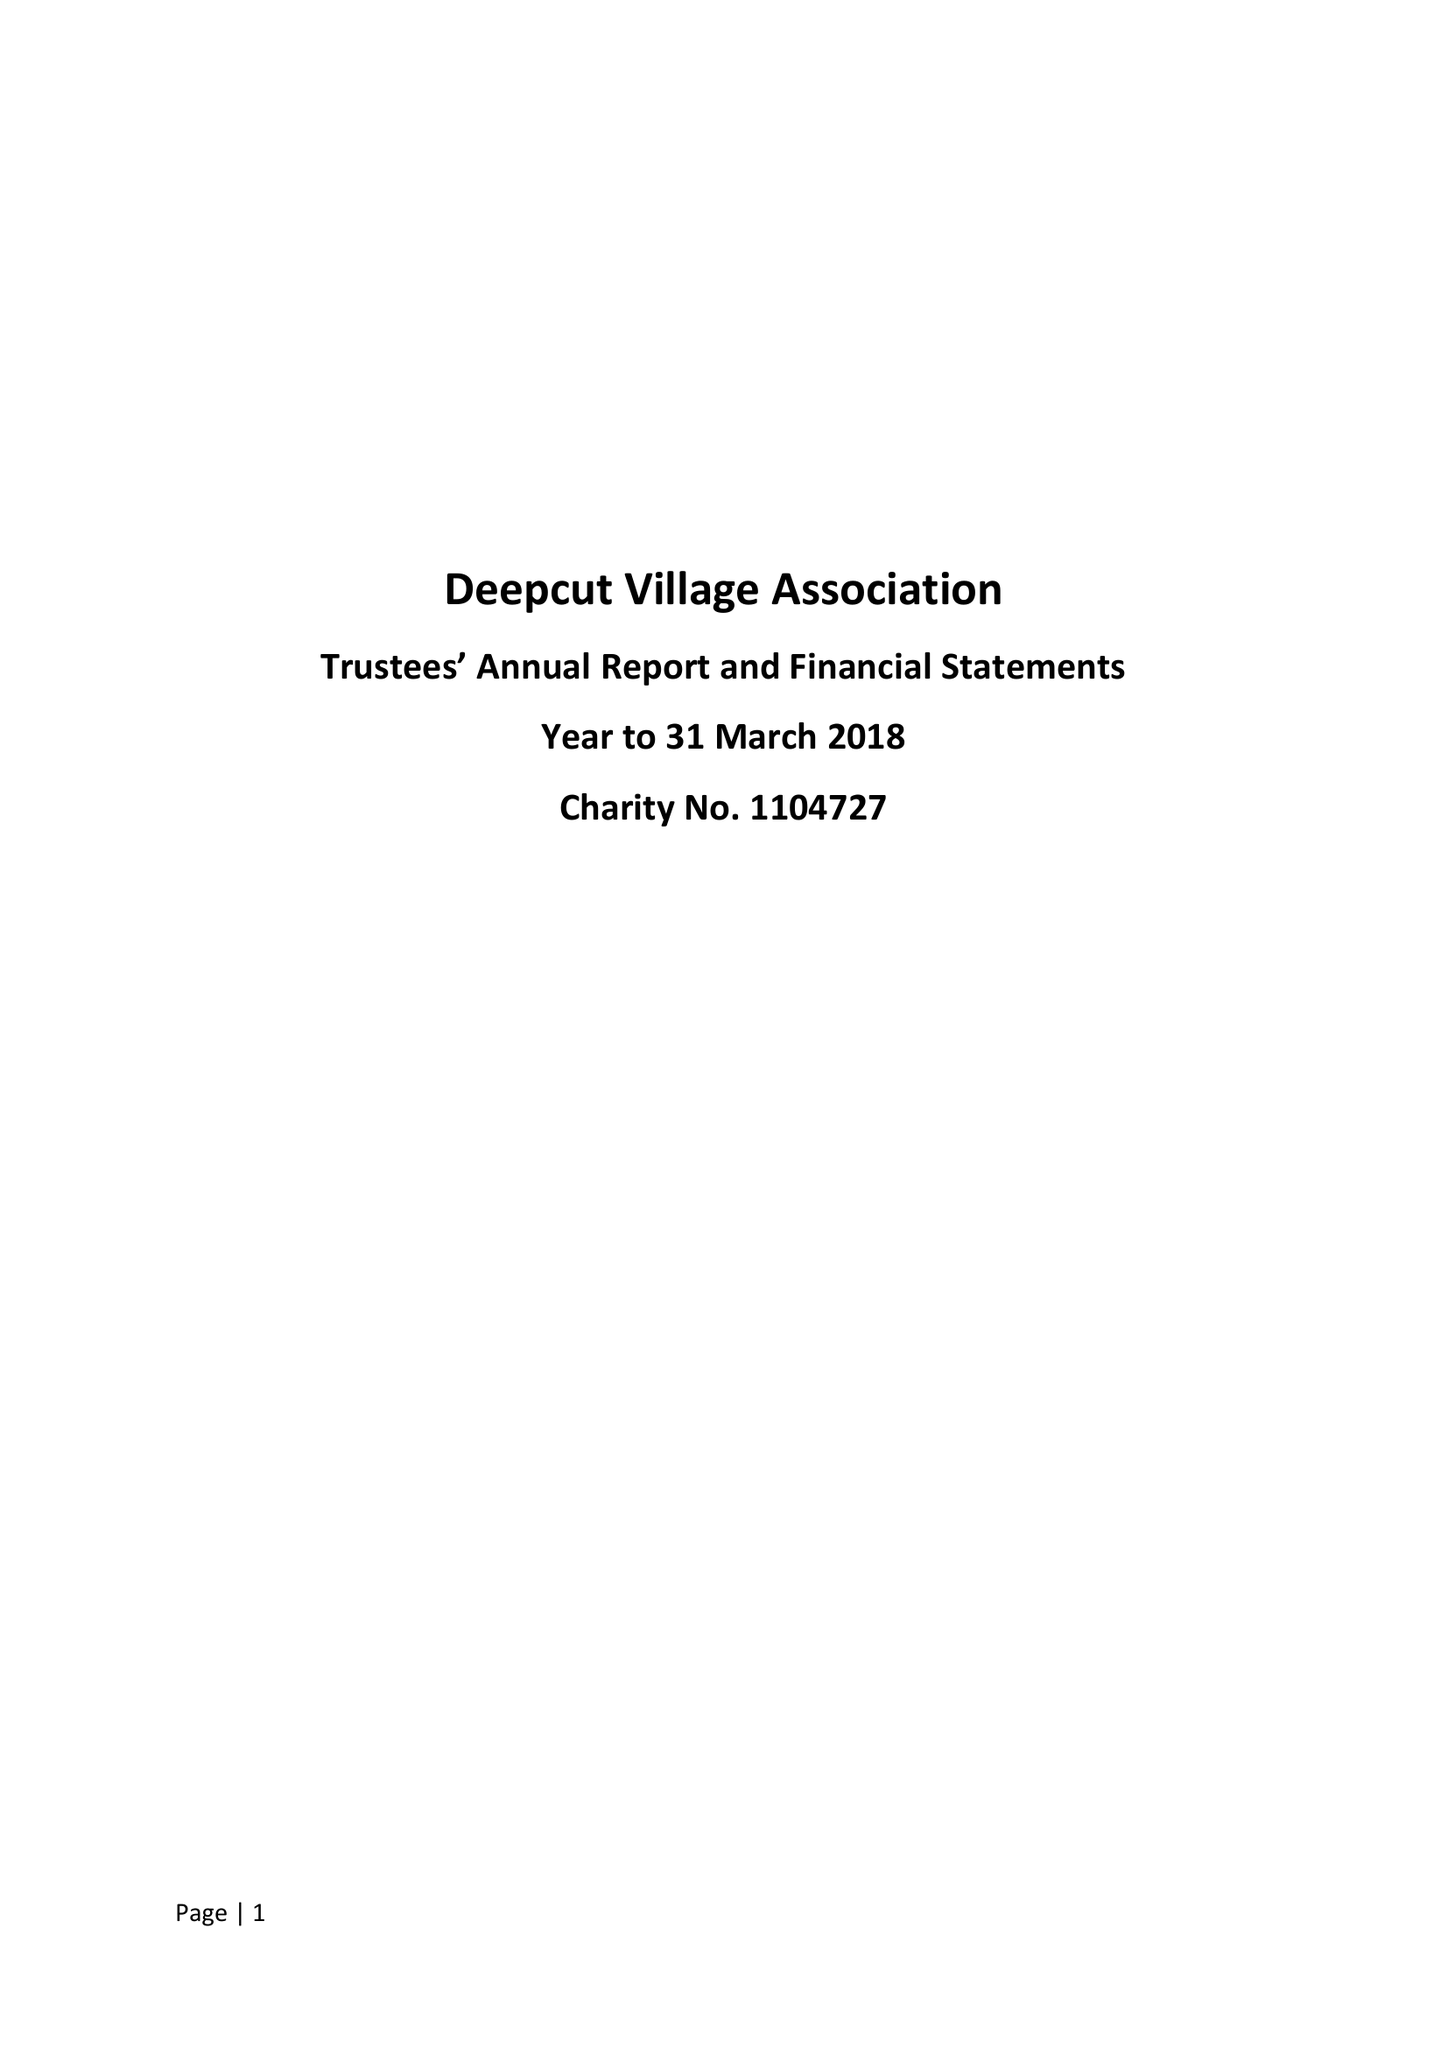What is the value for the charity_number?
Answer the question using a single word or phrase. 1104727 